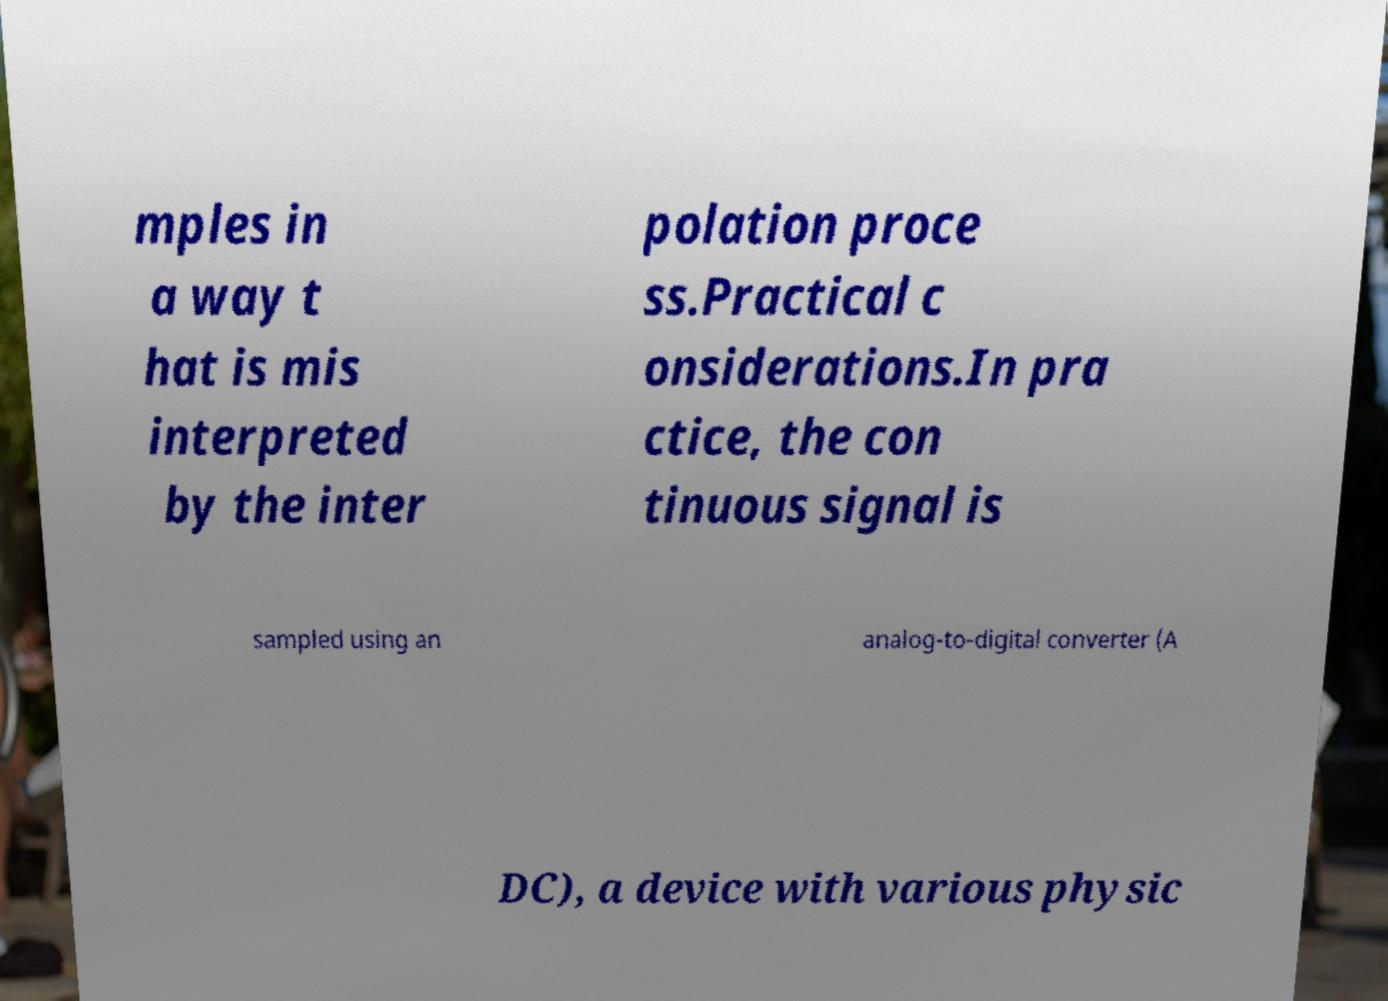Could you extract and type out the text from this image? mples in a way t hat is mis interpreted by the inter polation proce ss.Practical c onsiderations.In pra ctice, the con tinuous signal is sampled using an analog-to-digital converter (A DC), a device with various physic 